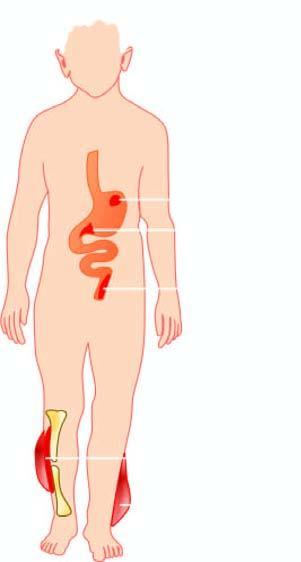how is diseases caused?
Answer the question using a single word or phrase. By streptococci 